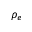<formula> <loc_0><loc_0><loc_500><loc_500>\rho _ { e }</formula> 